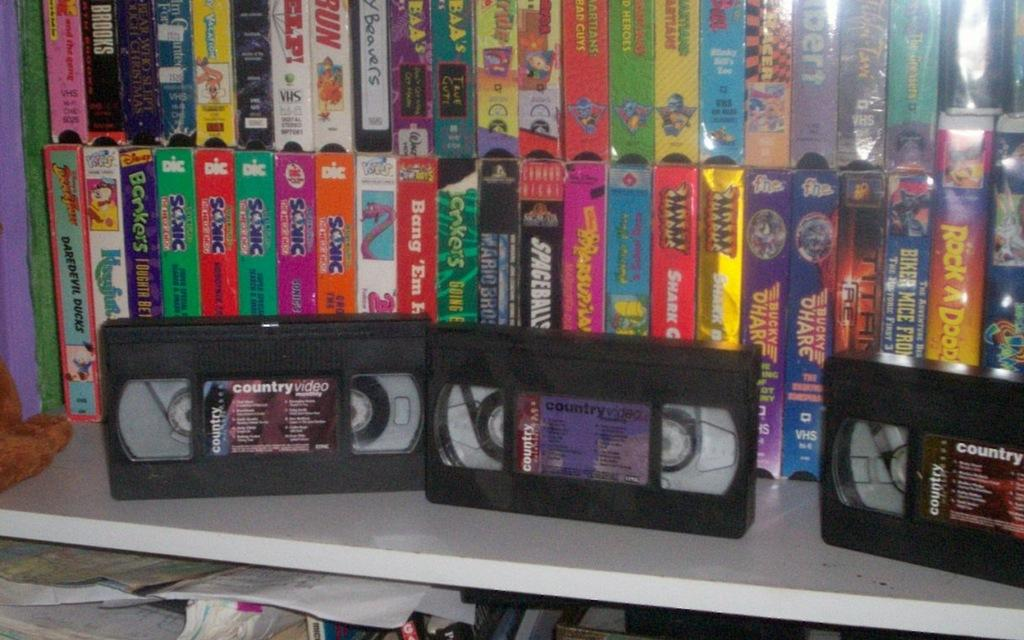<image>
Describe the image concisely. A number of VCRs are on a table, two of which say country. 